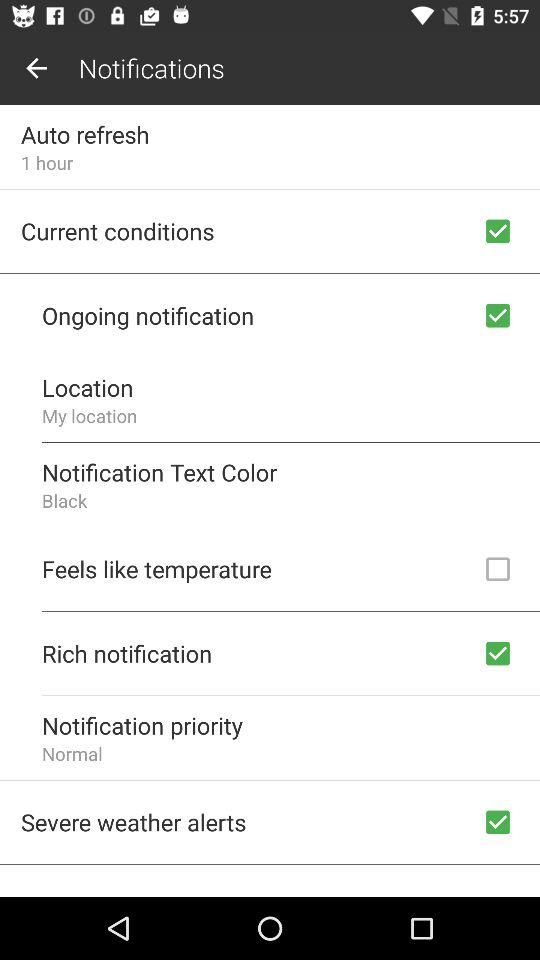What is the status of "Severe weather alerts"? The status is "on". 